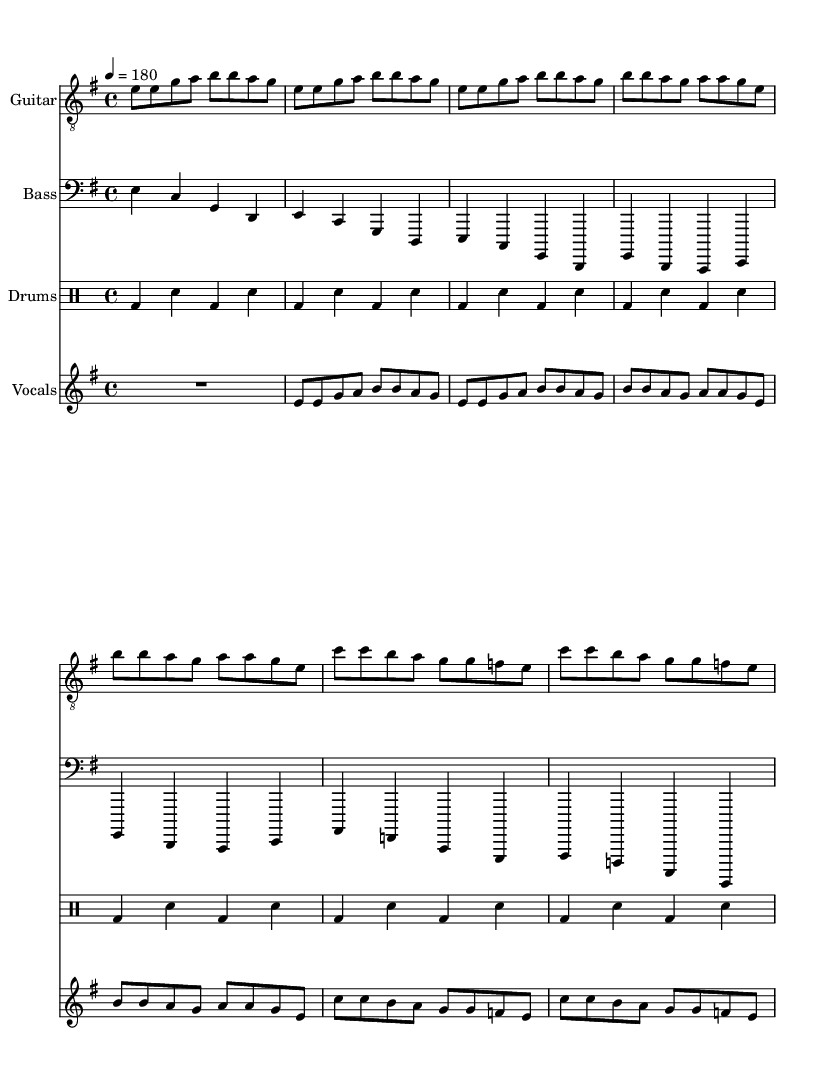What is the key signature of this music? The key signature is E minor, which includes one sharp (F#). This can be determined from the key signature at the beginning of the score, indicated by the note after the clef.
Answer: E minor What is the time signature of the piece? The time signature is 4/4, as indicated right after the key signature in the global music settings. This means there are four beats in each measure and the quarter note gets one beat.
Answer: 4/4 What is the tempo marking for this music? The tempo marking is 180, which is expressed in beats per minute (BPM). This can be found in the global section of the score, where the tempo instructions are provided.
Answer: 180 How many measures are in the chorus section? The chorus section consists of 8 measures in total. This involves examining the sheet music and counting the measures that are labeled as the chorus, which are clearly separated and repeated.
Answer: 8 What instrument types are featured in this piece? The piece features four instrumental types: Guitar, Bass, Drums, and Vocals. This is shown in the score layout where each part is distinctly labeled with its respective instrument name.
Answer: Guitar, Bass, Drums, Vocals What theme is critiqued in the lyrics? The lyrics critique the commercialization of sports. This is communicated through the words describing corporate sponsorships and financial motives overshadowing the sport's spirit, which can be directly interpreted from the lyrics provided.
Answer: Commercialization What lyric indicates a loss of traditional fan values? The lyrics "Gone are the days when fans came first" indicate a loss of traditional fan values. This is clearly stated in the chorus, which reflects disappointment in how fans are no longer prioritized.
Answer: Gone are the days when fans came first 